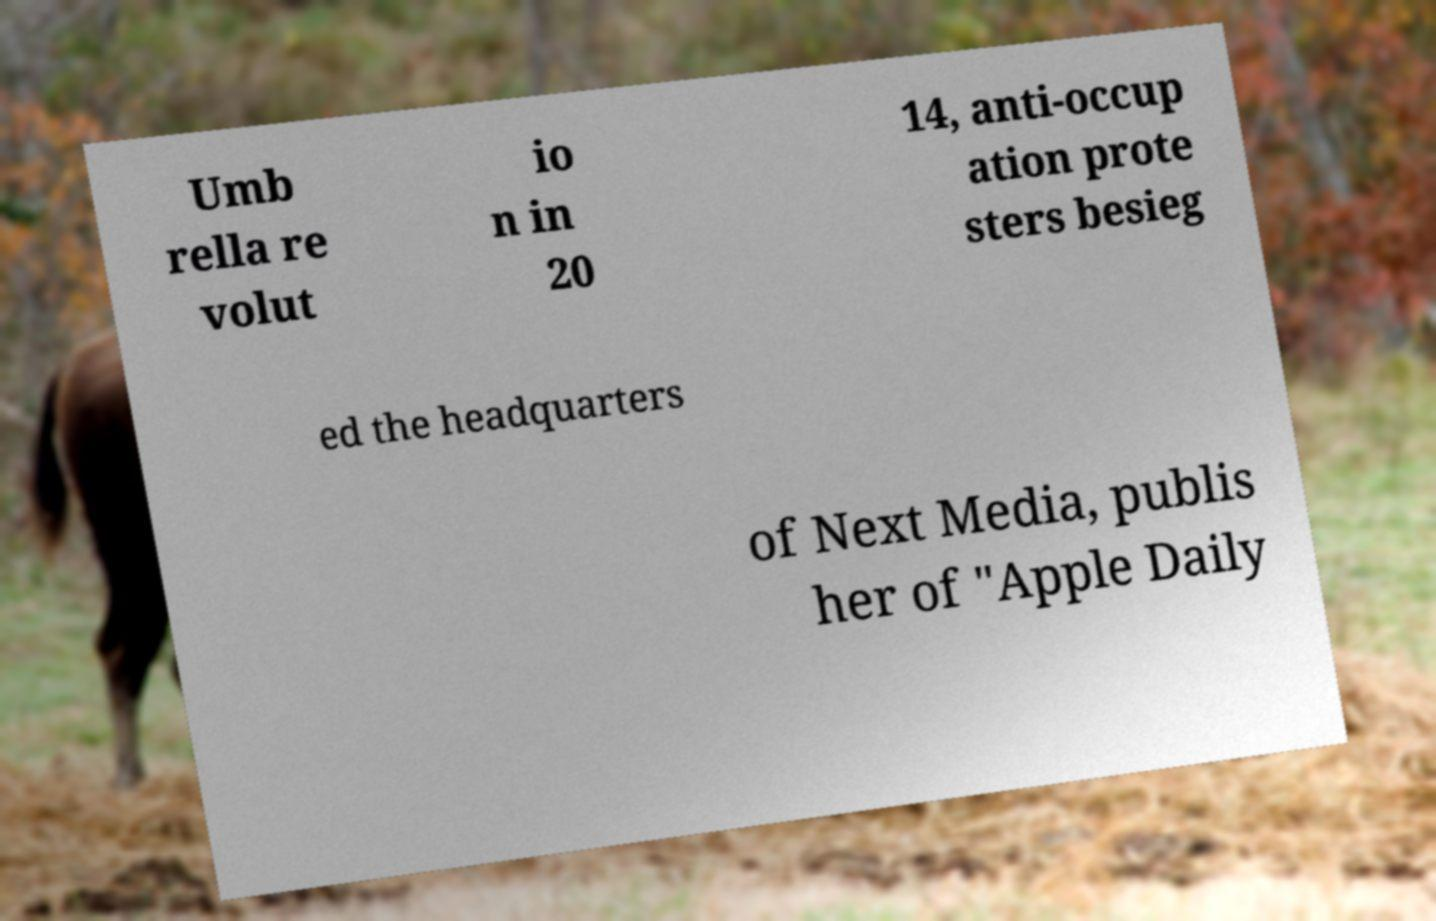Can you accurately transcribe the text from the provided image for me? Umb rella re volut io n in 20 14, anti-occup ation prote sters besieg ed the headquarters of Next Media, publis her of "Apple Daily 